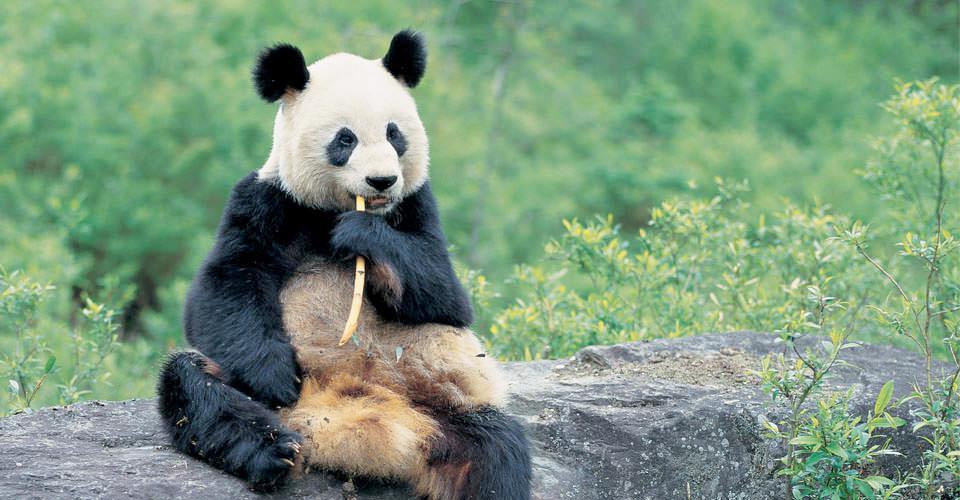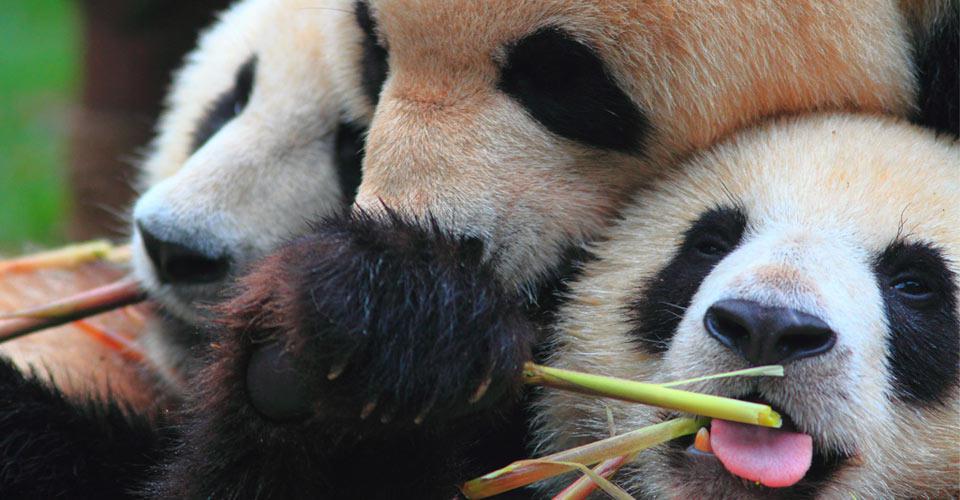The first image is the image on the left, the second image is the image on the right. Examine the images to the left and right. Is the description "There are no more than three panda bears." accurate? Answer yes or no. No. The first image is the image on the left, the second image is the image on the right. For the images displayed, is the sentence "There are two pandas climbing a branch." factually correct? Answer yes or no. No. 